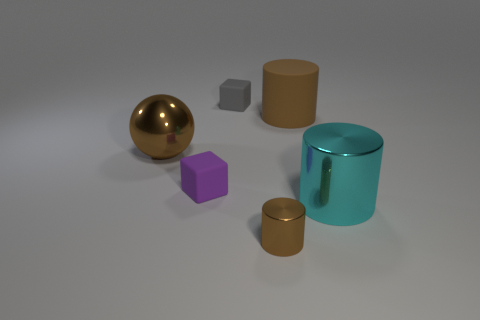Add 3 rubber balls. How many objects exist? 9 Subtract all balls. How many objects are left? 5 Subtract all brown things. Subtract all gray things. How many objects are left? 2 Add 2 large cylinders. How many large cylinders are left? 4 Add 3 tiny purple matte blocks. How many tiny purple matte blocks exist? 4 Subtract 0 yellow cubes. How many objects are left? 6 